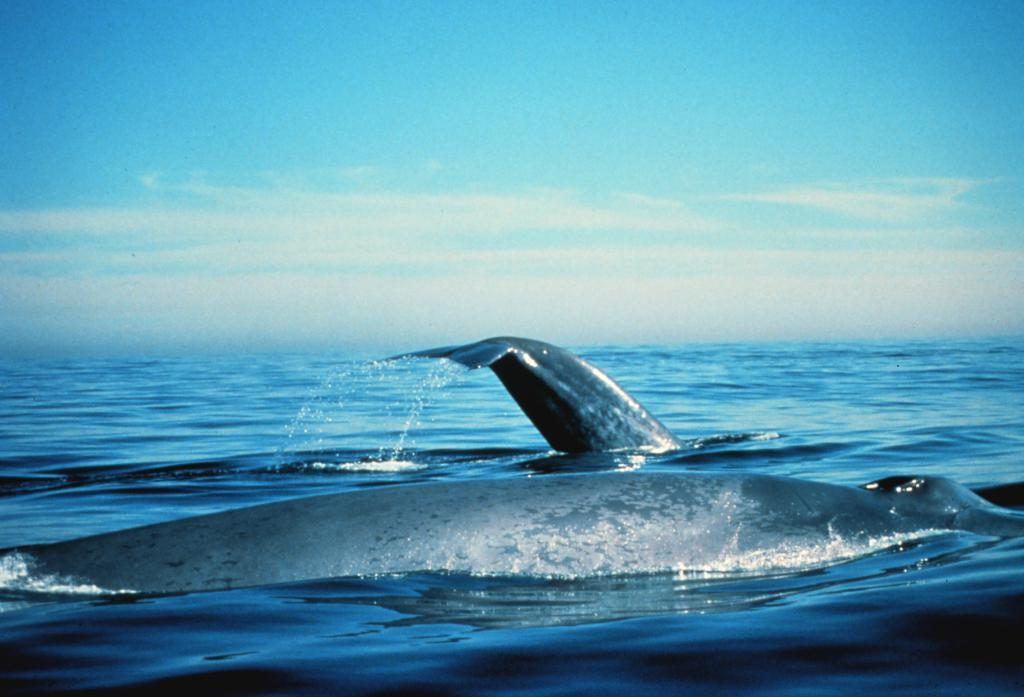What type of animals can be seen in the image? There are aquatic animals in the image. Where are the aquatic animals located? The aquatic animals are in the water. What can be seen in the background of the image? There is sky visible in the background of the image. What type of fuel is being used by the truck in the image? There is no truck present in the image; it features aquatic animals in the water. 